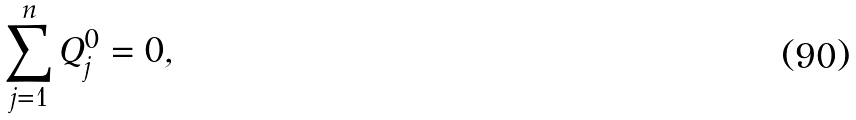Convert formula to latex. <formula><loc_0><loc_0><loc_500><loc_500>\sum _ { j = 1 } ^ { n } Q _ { j } ^ { 0 } = 0 ,</formula> 